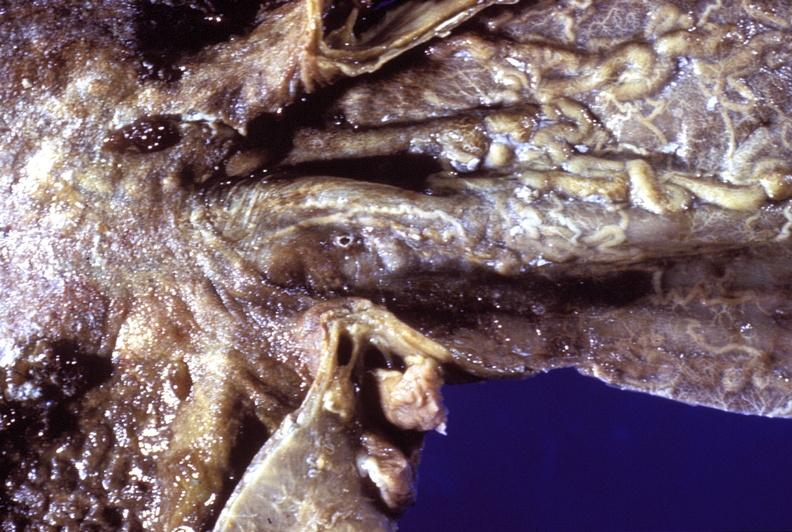what is present?
Answer the question using a single word or phrase. Gastrointestinal 